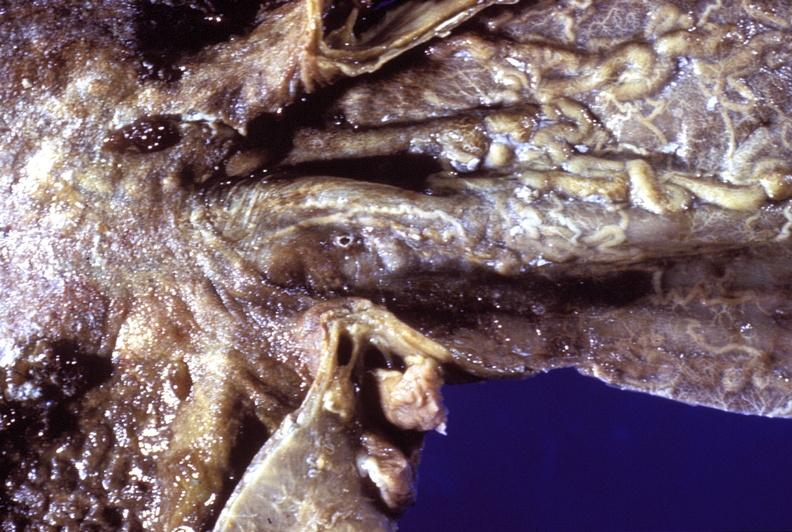what is present?
Answer the question using a single word or phrase. Gastrointestinal 